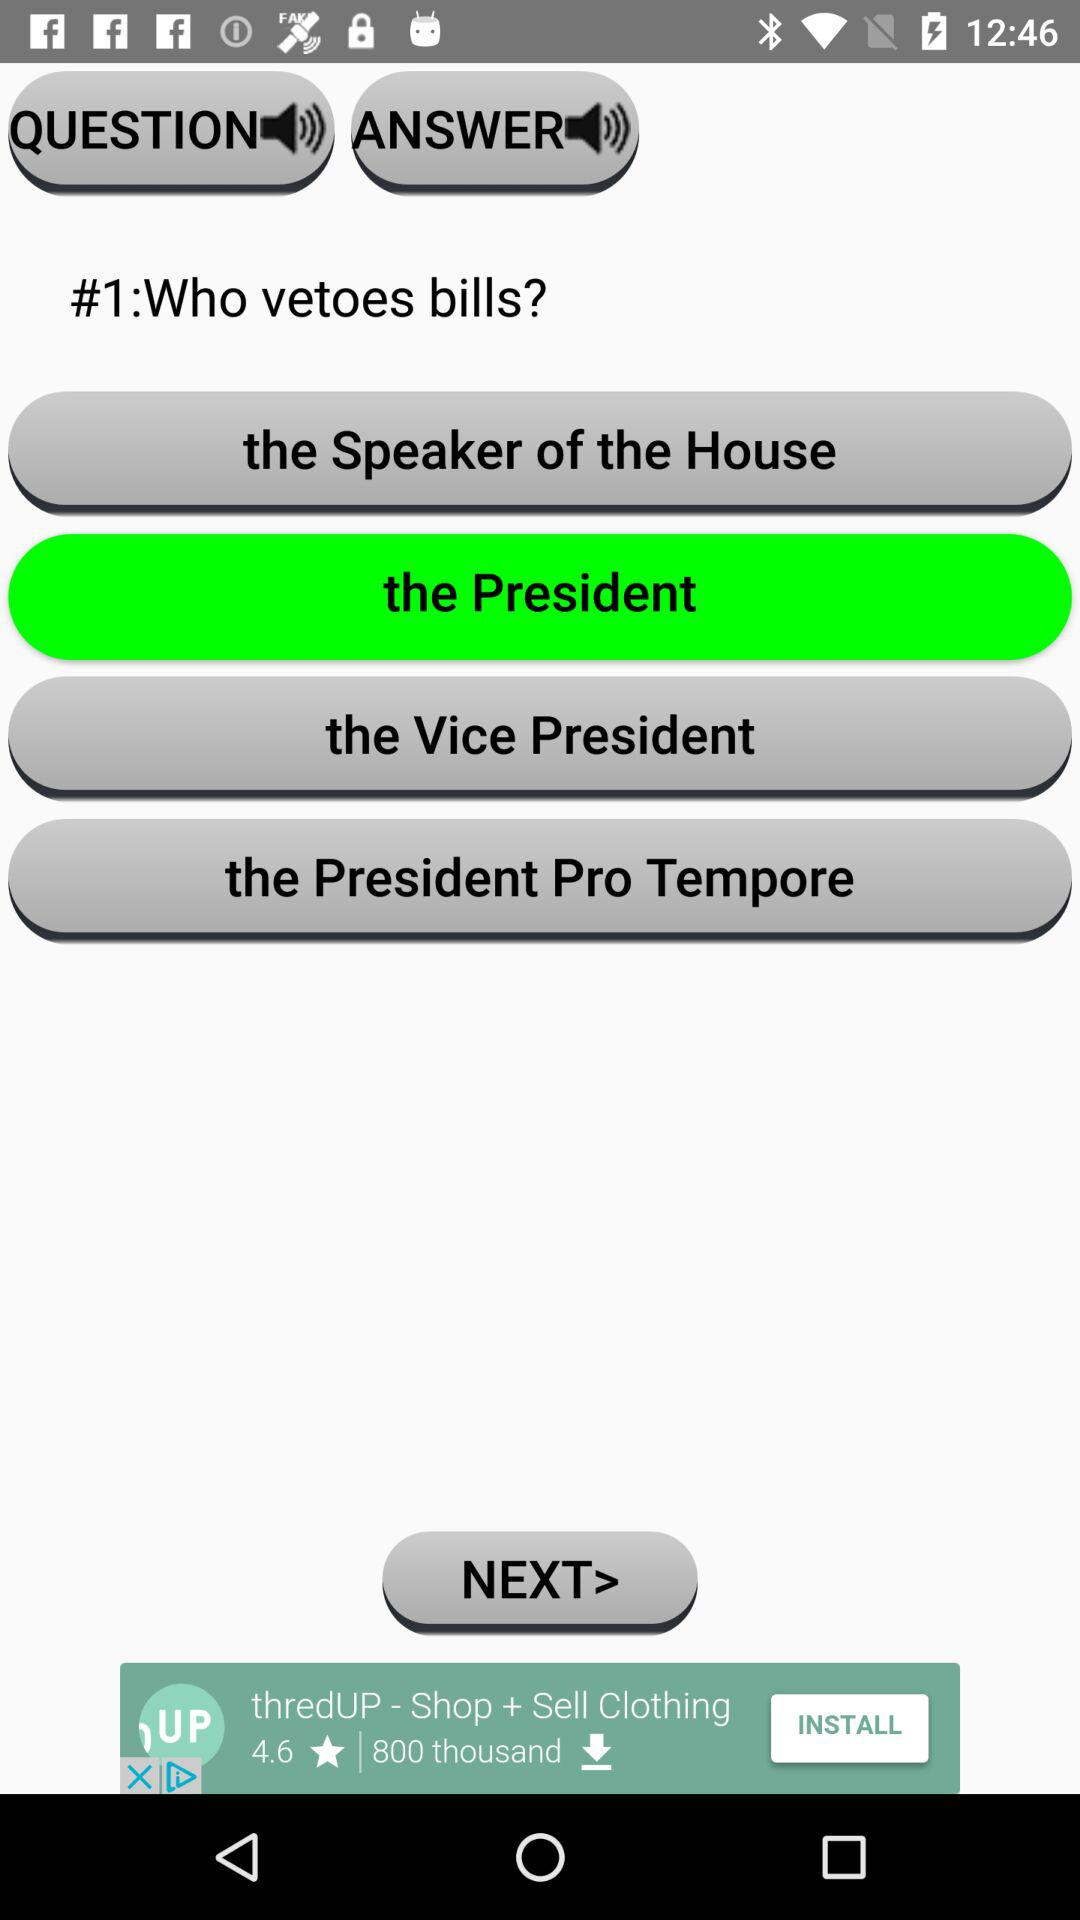What's the correct option to this question, "Who vetoes bills"? The correct option is "the President". 